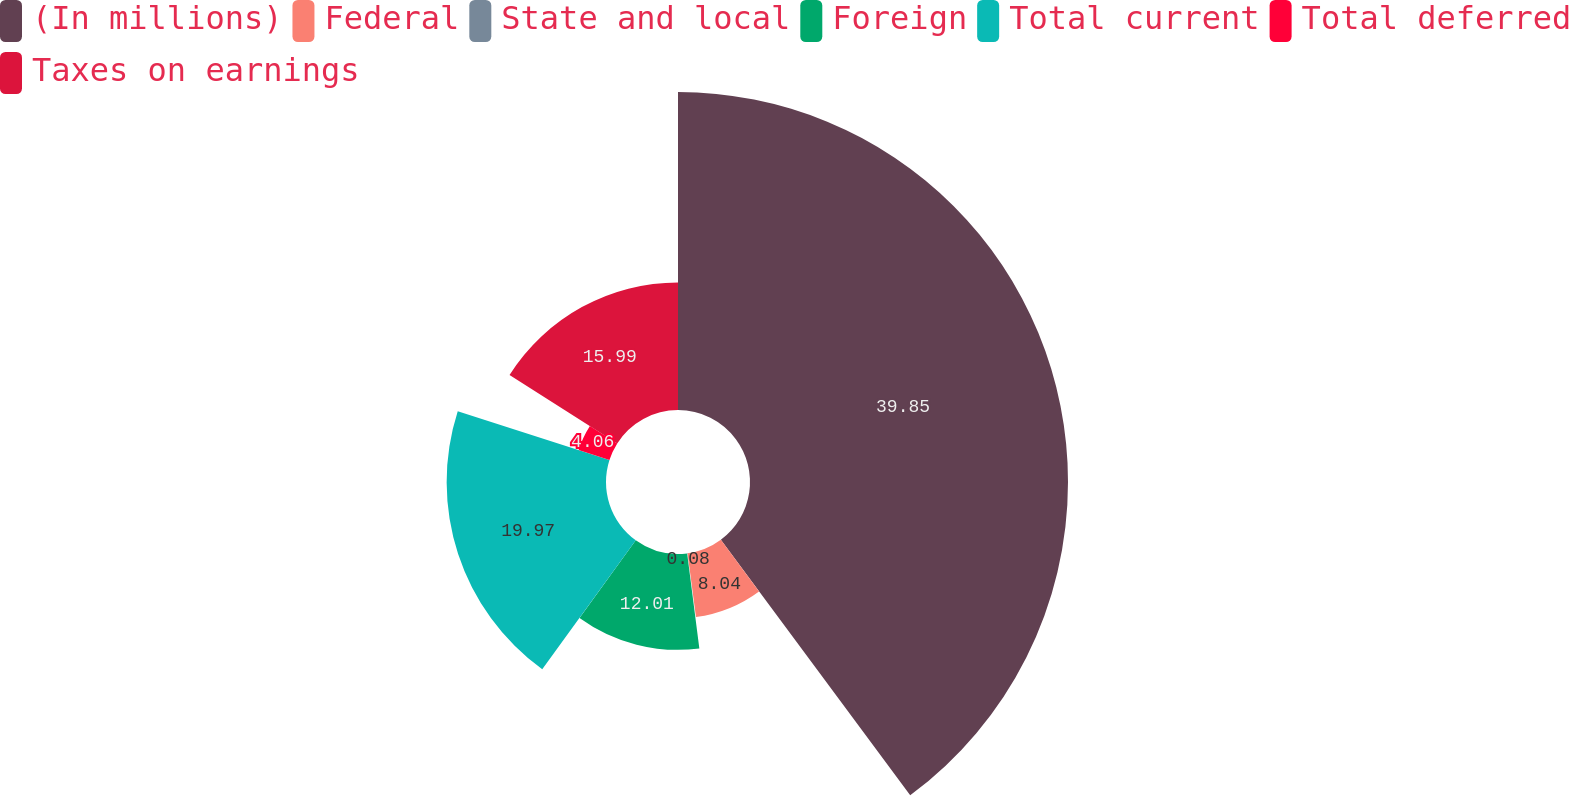Convert chart. <chart><loc_0><loc_0><loc_500><loc_500><pie_chart><fcel>(In millions)<fcel>Federal<fcel>State and local<fcel>Foreign<fcel>Total current<fcel>Total deferred<fcel>Taxes on earnings<nl><fcel>39.85%<fcel>8.04%<fcel>0.08%<fcel>12.01%<fcel>19.97%<fcel>4.06%<fcel>15.99%<nl></chart> 